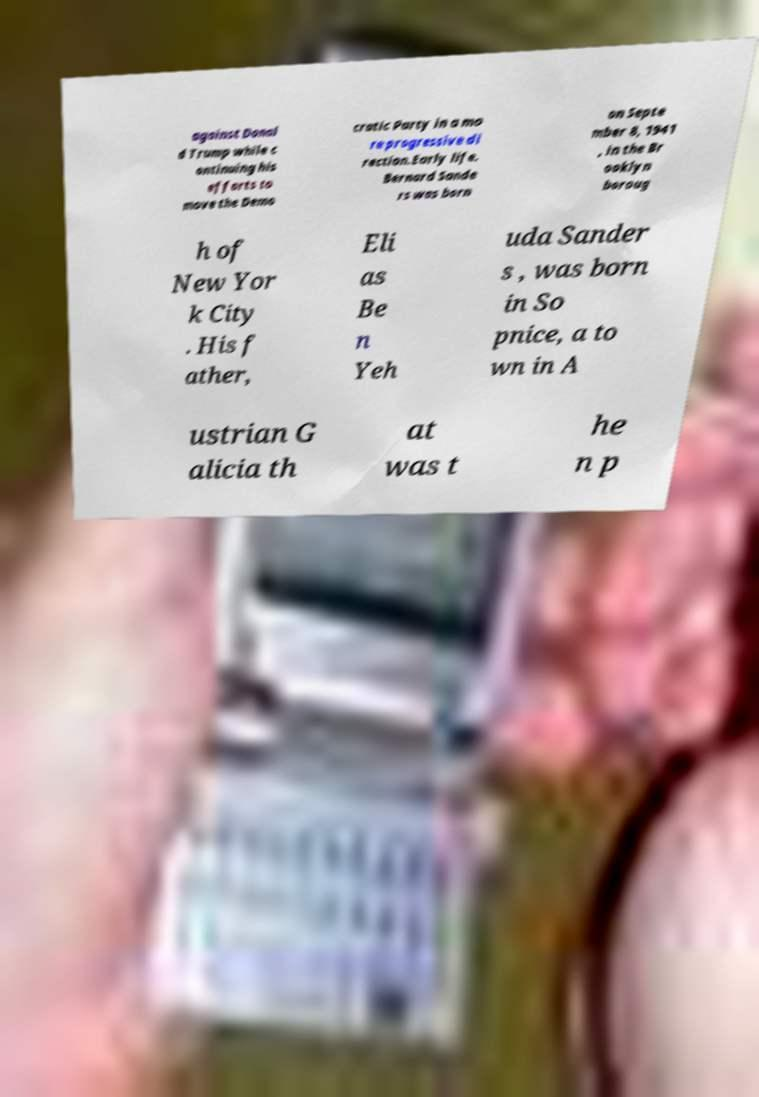For documentation purposes, I need the text within this image transcribed. Could you provide that? against Donal d Trump while c ontinuing his efforts to move the Demo cratic Party in a mo re progressive di rection.Early life. Bernard Sande rs was born on Septe mber 8, 1941 , in the Br ooklyn boroug h of New Yor k City . His f ather, Eli as Be n Yeh uda Sander s , was born in So pnice, a to wn in A ustrian G alicia th at was t he n p 